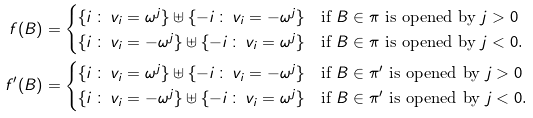Convert formula to latex. <formula><loc_0><loc_0><loc_500><loc_500>f ( B ) & = \begin{cases} \{ i \, \colon \, v _ { i } = \omega ^ { j } \} \uplus \{ - i \, \colon \, v _ { i } = - \omega ^ { j } \} & \text {if $B \in \pi$ is opened by $j > 0$} \\ \{ i \, \colon \, v _ { i } = - \omega ^ { j } \} \uplus \{ - i \, \colon \, v _ { i } = \omega ^ { j } \} & \text {if $B \in \pi$ is opened by $j < 0$.} \end{cases} \\ f ^ { \prime } ( B ) & = \begin{cases} \{ i \, \colon \, v _ { i } = \omega ^ { j } \} \uplus \{ - i \, \colon \, v _ { i } = - \omega ^ { j } \} & \text {if $B \in \pi^{\prime}$ is opened by $j > 0$} \\ \{ i \, \colon \, v _ { i } = - \omega ^ { j } \} \uplus \{ - i \, \colon \, v _ { i } = \omega ^ { j } \} & \text {if $B \in \pi^{\prime}$ is opened by $j < 0$.} \end{cases}</formula> 